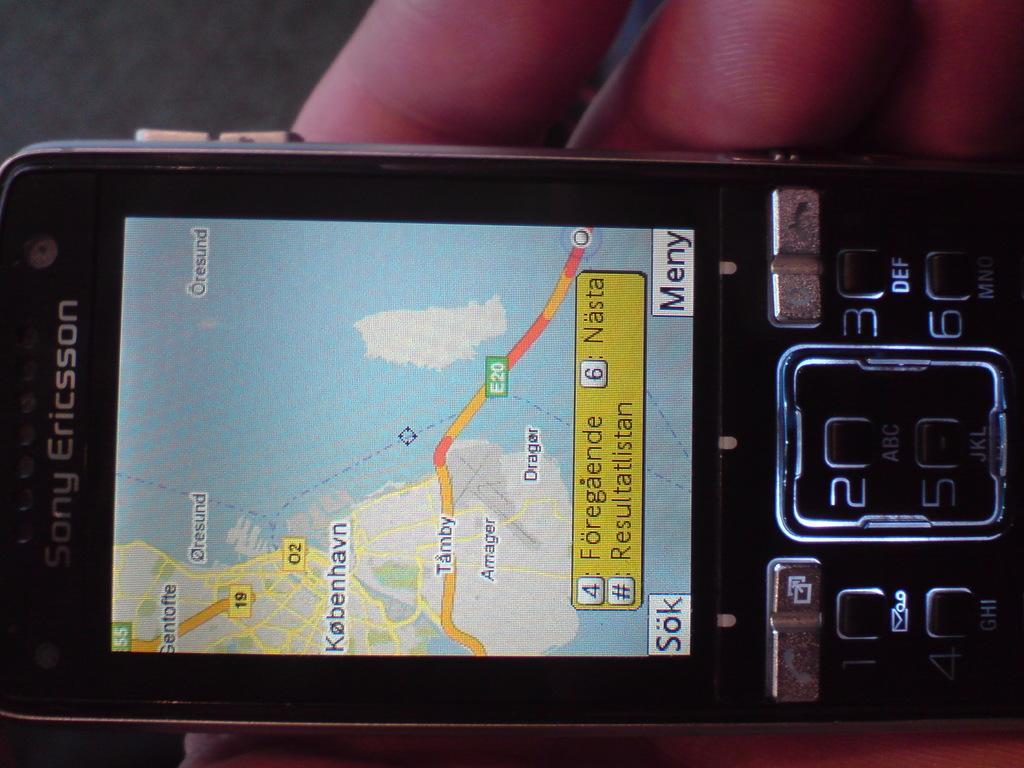<image>
Relay a brief, clear account of the picture shown. A sony Ericsson phone shows a map that includes the E20 road. 